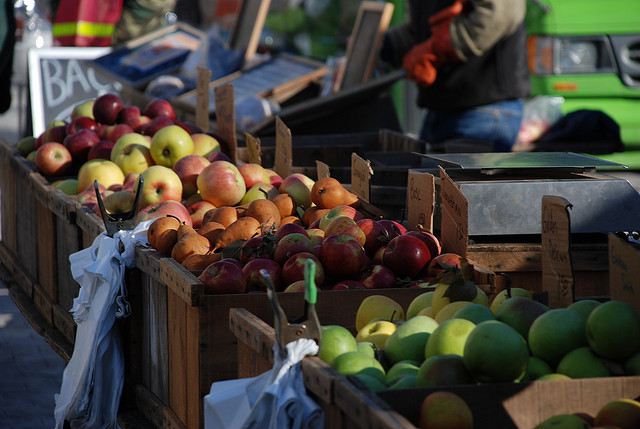<image>What fruit if the man reaching for? I don't know which fruit the man is reaching for. It could be an apple or there might be no man reaching for a fruit. What fruit if the man reaching for? I don't know what fruit the man is reaching for. I cannot see any fruit in the image. 